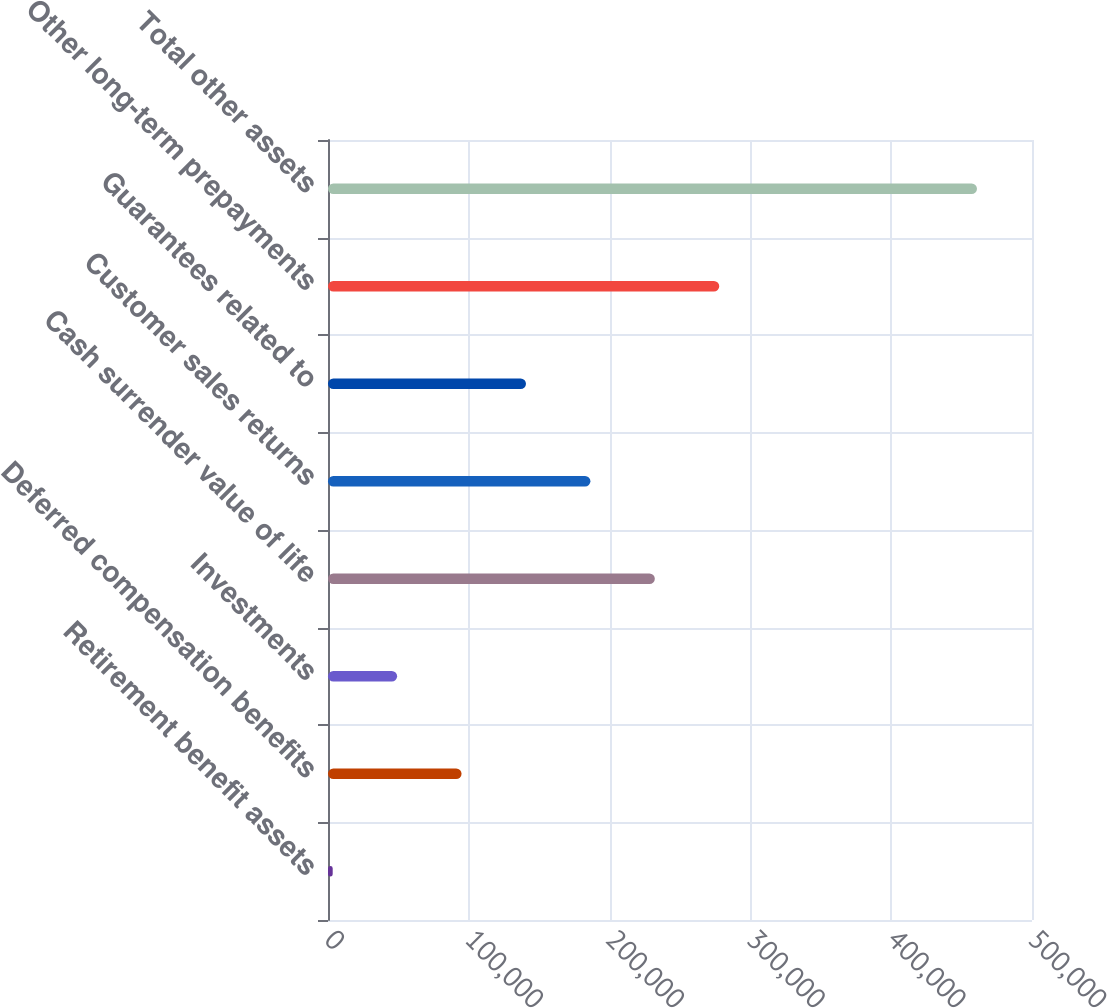Convert chart. <chart><loc_0><loc_0><loc_500><loc_500><bar_chart><fcel>Retirement benefit assets<fcel>Deferred compensation benefits<fcel>Investments<fcel>Cash surrender value of life<fcel>Customer sales returns<fcel>Guarantees related to<fcel>Other long-term prepayments<fcel>Total other assets<nl><fcel>3336<fcel>94852.4<fcel>49094.2<fcel>232127<fcel>186369<fcel>140611<fcel>277885<fcel>460918<nl></chart> 